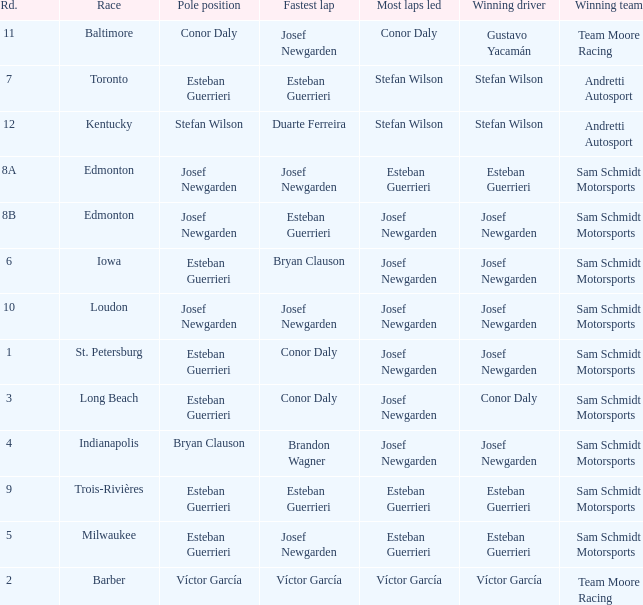What race did josef newgarden have the fastest lap and lead the most laps? Loudon. 